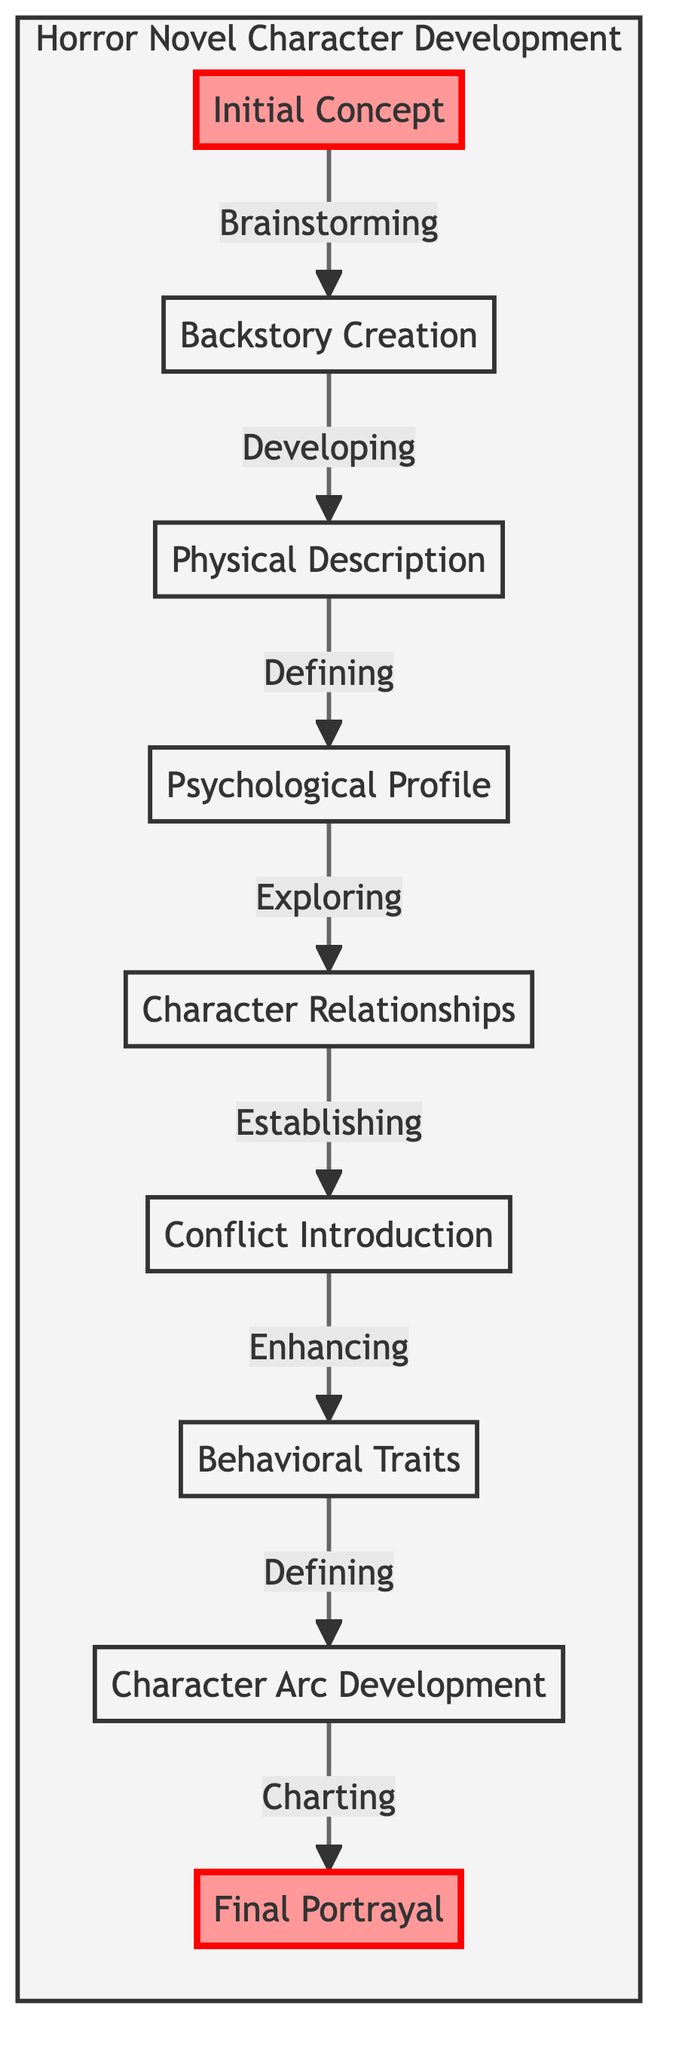What is the first stage in character development? The diagram indicates that the first stage is labeled "Initial Concept." This is the starting point in the flowchart's progression.
Answer: Initial Concept How many stages are in the character development process? By counting the elements listed in the flowchart, there are a total of nine distinct stages in the character development progression.
Answer: 9 Which stage follows the Backstory Creation? From the diagram, "Backstory Creation" is directly connected to the next stage, which is "Physical Description." This shows the sequential flow of development.
Answer: Physical Description What character trait is emphasized in the Psychological Profile stage? The details provided in the diagram specifically mention "Exploring fears and motivations," indicating a focus on understanding what drives the character psychologically.
Answer: Fears and motivations What two stages are highlighted in the diagram? The diagram marks "Initial Concept" and "Final Portrayal" as highlighted stages. This designation indicates their importance within the character development process.
Answer: Initial Concept, Final Portrayal What is the main task in the Conflict Introduction stage? According to the diagram, the Conflict Introduction stage involves "Introducing character-specific conflicts." This emphasizes adding tension and horror elements connected to the character.
Answer: Introducing character-specific conflicts Which two stages deal with the character's relationships? The stages that pertain to relationships are "Character Relationships" and the preceding stage "Psychological Profile." They focus on different aspects of interpersonal connections.
Answer: Character Relationships, Psychological Profile What character aspect is developed after Behavioral Traits? As shown in the diagram, Behavioral Traits lead into the subsequent stage, which is "Character Arc Development." This indicates a flow where behaviors inform the character’s overall growth.
Answer: Character Arc Development What signifies the final stage in this development process? The final stage is clearly indicated as "Final Portrayal," which culminates the character development journey and reflects the ultimate representation of the character.
Answer: Final Portrayal 